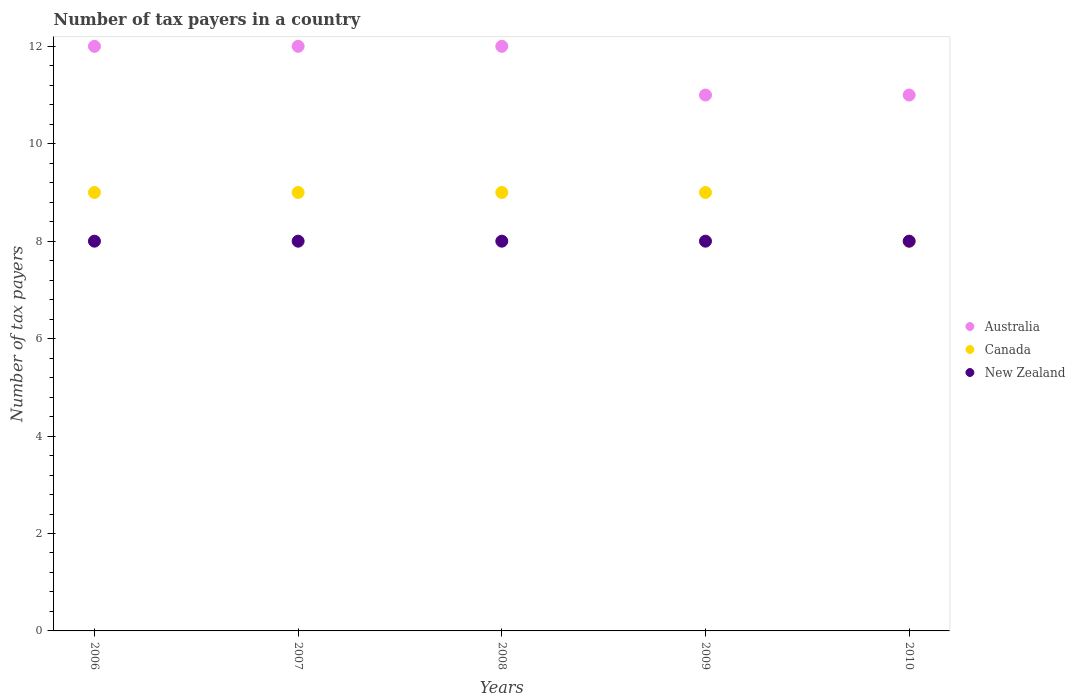What is the number of tax payers in in Australia in 2006?
Provide a succinct answer. 12. Across all years, what is the maximum number of tax payers in in Australia?
Offer a terse response. 12. Across all years, what is the minimum number of tax payers in in New Zealand?
Offer a very short reply. 8. In which year was the number of tax payers in in Canada minimum?
Offer a very short reply. 2010. What is the total number of tax payers in in New Zealand in the graph?
Keep it short and to the point. 40. What is the difference between the number of tax payers in in Canada in 2006 and the number of tax payers in in Australia in 2008?
Your response must be concise. -3. In the year 2007, what is the difference between the number of tax payers in in Canada and number of tax payers in in New Zealand?
Offer a terse response. 1. In how many years, is the number of tax payers in in Australia greater than 10.8?
Your response must be concise. 5. Is the number of tax payers in in Australia in 2007 less than that in 2010?
Offer a terse response. No. What is the difference between the highest and the second highest number of tax payers in in Australia?
Make the answer very short. 0. Is it the case that in every year, the sum of the number of tax payers in in Canada and number of tax payers in in Australia  is greater than the number of tax payers in in New Zealand?
Keep it short and to the point. Yes. Does the number of tax payers in in Australia monotonically increase over the years?
Make the answer very short. No. Is the number of tax payers in in Canada strictly greater than the number of tax payers in in Australia over the years?
Provide a succinct answer. No. Is the number of tax payers in in Canada strictly less than the number of tax payers in in Australia over the years?
Ensure brevity in your answer.  Yes. How many years are there in the graph?
Ensure brevity in your answer.  5. What is the difference between two consecutive major ticks on the Y-axis?
Provide a succinct answer. 2. Where does the legend appear in the graph?
Offer a terse response. Center right. How are the legend labels stacked?
Make the answer very short. Vertical. What is the title of the graph?
Keep it short and to the point. Number of tax payers in a country. Does "Somalia" appear as one of the legend labels in the graph?
Make the answer very short. No. What is the label or title of the X-axis?
Make the answer very short. Years. What is the label or title of the Y-axis?
Keep it short and to the point. Number of tax payers. What is the Number of tax payers of Australia in 2007?
Offer a very short reply. 12. What is the Number of tax payers of New Zealand in 2008?
Your answer should be very brief. 8. What is the Number of tax payers in Australia in 2010?
Your answer should be compact. 11. Across all years, what is the maximum Number of tax payers in Australia?
Your answer should be compact. 12. Across all years, what is the maximum Number of tax payers in Canada?
Keep it short and to the point. 9. Across all years, what is the minimum Number of tax payers of Canada?
Ensure brevity in your answer.  8. Across all years, what is the minimum Number of tax payers in New Zealand?
Provide a short and direct response. 8. What is the total Number of tax payers of New Zealand in the graph?
Your answer should be very brief. 40. What is the difference between the Number of tax payers in Canada in 2006 and that in 2007?
Provide a short and direct response. 0. What is the difference between the Number of tax payers in New Zealand in 2006 and that in 2008?
Offer a very short reply. 0. What is the difference between the Number of tax payers of New Zealand in 2006 and that in 2009?
Your response must be concise. 0. What is the difference between the Number of tax payers in Australia in 2006 and that in 2010?
Ensure brevity in your answer.  1. What is the difference between the Number of tax payers in Canada in 2006 and that in 2010?
Your answer should be compact. 1. What is the difference between the Number of tax payers of New Zealand in 2006 and that in 2010?
Offer a terse response. 0. What is the difference between the Number of tax payers in Australia in 2007 and that in 2008?
Keep it short and to the point. 0. What is the difference between the Number of tax payers of Canada in 2007 and that in 2008?
Offer a very short reply. 0. What is the difference between the Number of tax payers of New Zealand in 2007 and that in 2008?
Ensure brevity in your answer.  0. What is the difference between the Number of tax payers in New Zealand in 2007 and that in 2010?
Make the answer very short. 0. What is the difference between the Number of tax payers in Australia in 2008 and that in 2009?
Provide a short and direct response. 1. What is the difference between the Number of tax payers in Canada in 2008 and that in 2009?
Offer a terse response. 0. What is the difference between the Number of tax payers in New Zealand in 2008 and that in 2009?
Your answer should be compact. 0. What is the difference between the Number of tax payers of Australia in 2008 and that in 2010?
Your response must be concise. 1. What is the difference between the Number of tax payers in New Zealand in 2008 and that in 2010?
Offer a terse response. 0. What is the difference between the Number of tax payers in Australia in 2009 and that in 2010?
Keep it short and to the point. 0. What is the difference between the Number of tax payers in New Zealand in 2009 and that in 2010?
Keep it short and to the point. 0. What is the difference between the Number of tax payers of Canada in 2006 and the Number of tax payers of New Zealand in 2007?
Give a very brief answer. 1. What is the difference between the Number of tax payers of Australia in 2006 and the Number of tax payers of Canada in 2008?
Provide a succinct answer. 3. What is the difference between the Number of tax payers in Canada in 2006 and the Number of tax payers in New Zealand in 2008?
Offer a terse response. 1. What is the difference between the Number of tax payers of Australia in 2006 and the Number of tax payers of Canada in 2009?
Your response must be concise. 3. What is the difference between the Number of tax payers in Australia in 2006 and the Number of tax payers in New Zealand in 2009?
Ensure brevity in your answer.  4. What is the difference between the Number of tax payers in Canada in 2006 and the Number of tax payers in New Zealand in 2009?
Your response must be concise. 1. What is the difference between the Number of tax payers in Australia in 2006 and the Number of tax payers in Canada in 2010?
Give a very brief answer. 4. What is the difference between the Number of tax payers in Australia in 2006 and the Number of tax payers in New Zealand in 2010?
Ensure brevity in your answer.  4. What is the difference between the Number of tax payers in Australia in 2007 and the Number of tax payers in New Zealand in 2008?
Your answer should be compact. 4. What is the difference between the Number of tax payers in Australia in 2007 and the Number of tax payers in New Zealand in 2009?
Provide a succinct answer. 4. What is the difference between the Number of tax payers in Canada in 2007 and the Number of tax payers in New Zealand in 2009?
Give a very brief answer. 1. What is the difference between the Number of tax payers of Australia in 2007 and the Number of tax payers of New Zealand in 2010?
Offer a very short reply. 4. What is the difference between the Number of tax payers in Canada in 2007 and the Number of tax payers in New Zealand in 2010?
Your answer should be compact. 1. What is the difference between the Number of tax payers of Canada in 2008 and the Number of tax payers of New Zealand in 2009?
Your answer should be compact. 1. What is the difference between the Number of tax payers in Canada in 2009 and the Number of tax payers in New Zealand in 2010?
Give a very brief answer. 1. What is the average Number of tax payers in Australia per year?
Keep it short and to the point. 11.6. In the year 2006, what is the difference between the Number of tax payers in Australia and Number of tax payers in Canada?
Keep it short and to the point. 3. In the year 2007, what is the difference between the Number of tax payers in Canada and Number of tax payers in New Zealand?
Offer a terse response. 1. In the year 2008, what is the difference between the Number of tax payers in Australia and Number of tax payers in Canada?
Offer a terse response. 3. In the year 2008, what is the difference between the Number of tax payers in Canada and Number of tax payers in New Zealand?
Your answer should be very brief. 1. In the year 2009, what is the difference between the Number of tax payers in Canada and Number of tax payers in New Zealand?
Provide a short and direct response. 1. In the year 2010, what is the difference between the Number of tax payers of Australia and Number of tax payers of New Zealand?
Offer a terse response. 3. What is the ratio of the Number of tax payers in Canada in 2006 to that in 2007?
Give a very brief answer. 1. What is the ratio of the Number of tax payers of Canada in 2006 to that in 2009?
Offer a terse response. 1. What is the ratio of the Number of tax payers of New Zealand in 2007 to that in 2008?
Give a very brief answer. 1. What is the ratio of the Number of tax payers in Australia in 2007 to that in 2010?
Your answer should be very brief. 1.09. What is the ratio of the Number of tax payers in Canada in 2007 to that in 2010?
Your answer should be very brief. 1.12. What is the ratio of the Number of tax payers of New Zealand in 2007 to that in 2010?
Ensure brevity in your answer.  1. What is the ratio of the Number of tax payers in Australia in 2008 to that in 2009?
Provide a succinct answer. 1.09. What is the ratio of the Number of tax payers of New Zealand in 2008 to that in 2009?
Your answer should be very brief. 1. What is the ratio of the Number of tax payers in New Zealand in 2009 to that in 2010?
Your answer should be very brief. 1. What is the difference between the highest and the lowest Number of tax payers of New Zealand?
Your answer should be compact. 0. 